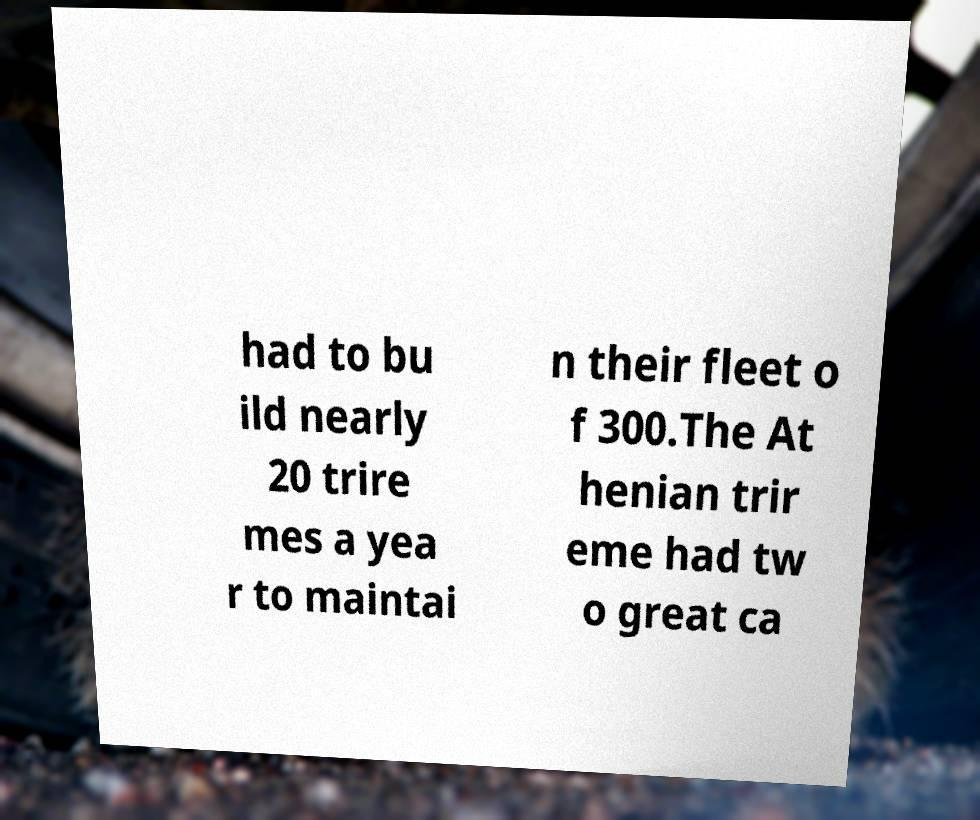There's text embedded in this image that I need extracted. Can you transcribe it verbatim? had to bu ild nearly 20 trire mes a yea r to maintai n their fleet o f 300.The At henian trir eme had tw o great ca 